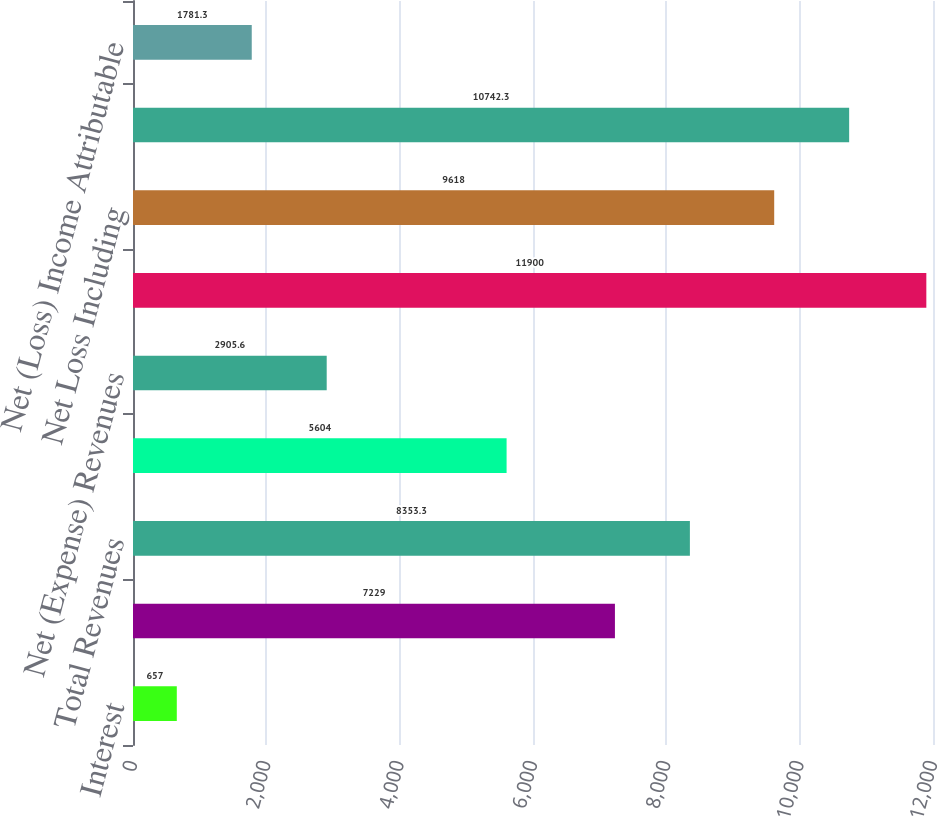<chart> <loc_0><loc_0><loc_500><loc_500><bar_chart><fcel>Interest<fcel>Other<fcel>Total Revenues<fcel>Interest Expense<fcel>Net (Expense) Revenues<fcel>Non-Interest Expenses<fcel>Net Loss Including<fcel>Net Loss Attributable to<fcel>Net (Loss) Income Attributable<nl><fcel>657<fcel>7229<fcel>8353.3<fcel>5604<fcel>2905.6<fcel>11900<fcel>9618<fcel>10742.3<fcel>1781.3<nl></chart> 